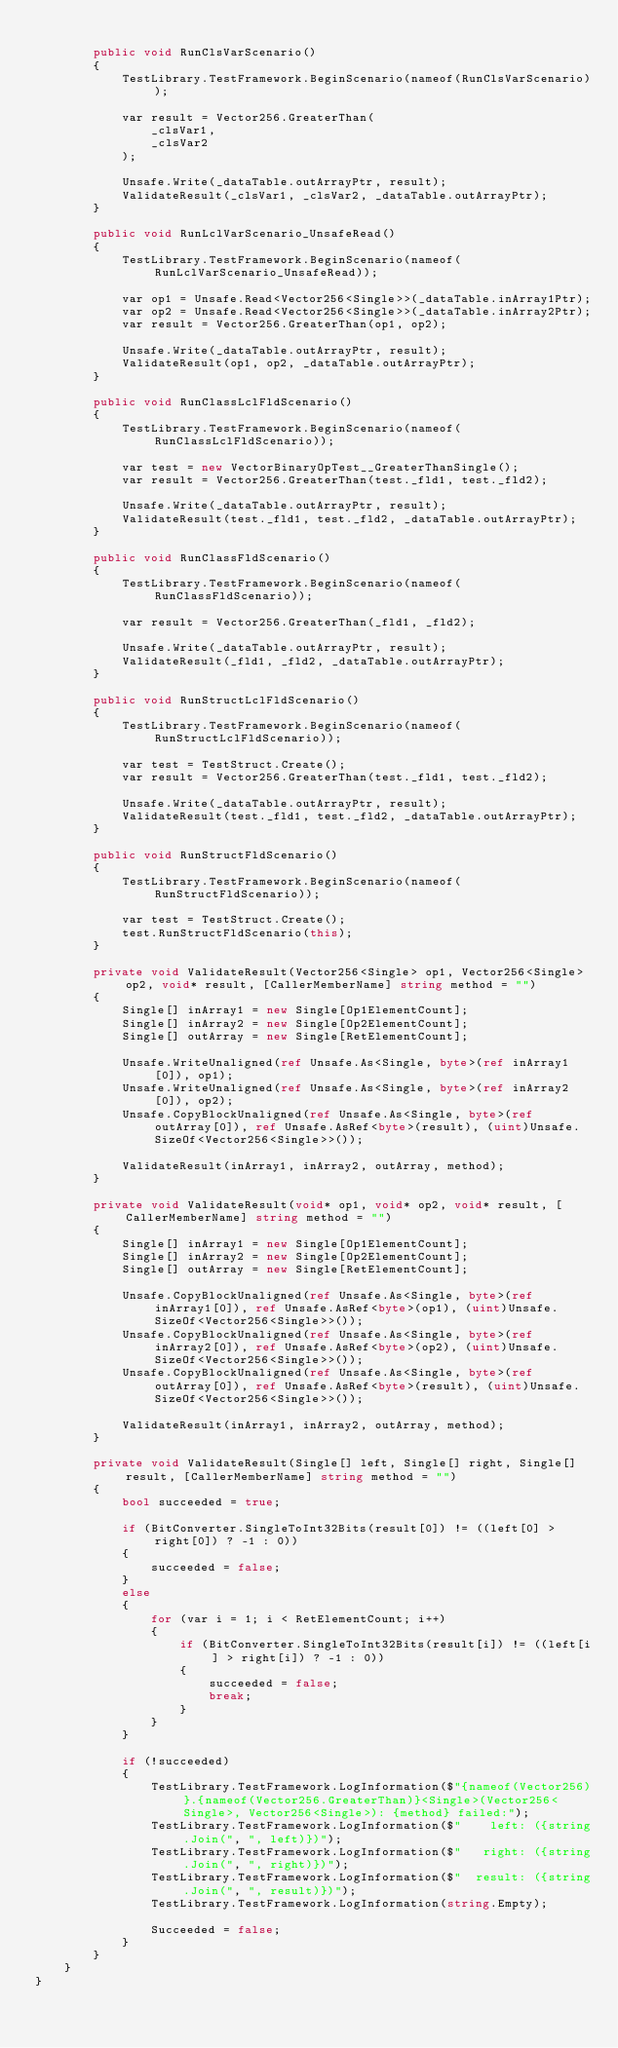Convert code to text. <code><loc_0><loc_0><loc_500><loc_500><_C#_>
        public void RunClsVarScenario()
        {
            TestLibrary.TestFramework.BeginScenario(nameof(RunClsVarScenario));

            var result = Vector256.GreaterThan(
                _clsVar1,
                _clsVar2
            );

            Unsafe.Write(_dataTable.outArrayPtr, result);
            ValidateResult(_clsVar1, _clsVar2, _dataTable.outArrayPtr);
        }

        public void RunLclVarScenario_UnsafeRead()
        {
            TestLibrary.TestFramework.BeginScenario(nameof(RunLclVarScenario_UnsafeRead));

            var op1 = Unsafe.Read<Vector256<Single>>(_dataTable.inArray1Ptr);
            var op2 = Unsafe.Read<Vector256<Single>>(_dataTable.inArray2Ptr);
            var result = Vector256.GreaterThan(op1, op2);

            Unsafe.Write(_dataTable.outArrayPtr, result);
            ValidateResult(op1, op2, _dataTable.outArrayPtr);
        }

        public void RunClassLclFldScenario()
        {
            TestLibrary.TestFramework.BeginScenario(nameof(RunClassLclFldScenario));

            var test = new VectorBinaryOpTest__GreaterThanSingle();
            var result = Vector256.GreaterThan(test._fld1, test._fld2);

            Unsafe.Write(_dataTable.outArrayPtr, result);
            ValidateResult(test._fld1, test._fld2, _dataTable.outArrayPtr);
        }

        public void RunClassFldScenario()
        {
            TestLibrary.TestFramework.BeginScenario(nameof(RunClassFldScenario));

            var result = Vector256.GreaterThan(_fld1, _fld2);

            Unsafe.Write(_dataTable.outArrayPtr, result);
            ValidateResult(_fld1, _fld2, _dataTable.outArrayPtr);
        }

        public void RunStructLclFldScenario()
        {
            TestLibrary.TestFramework.BeginScenario(nameof(RunStructLclFldScenario));

            var test = TestStruct.Create();
            var result = Vector256.GreaterThan(test._fld1, test._fld2);

            Unsafe.Write(_dataTable.outArrayPtr, result);
            ValidateResult(test._fld1, test._fld2, _dataTable.outArrayPtr);
        }

        public void RunStructFldScenario()
        {
            TestLibrary.TestFramework.BeginScenario(nameof(RunStructFldScenario));

            var test = TestStruct.Create();
            test.RunStructFldScenario(this);
        }

        private void ValidateResult(Vector256<Single> op1, Vector256<Single> op2, void* result, [CallerMemberName] string method = "")
        {
            Single[] inArray1 = new Single[Op1ElementCount];
            Single[] inArray2 = new Single[Op2ElementCount];
            Single[] outArray = new Single[RetElementCount];

            Unsafe.WriteUnaligned(ref Unsafe.As<Single, byte>(ref inArray1[0]), op1);
            Unsafe.WriteUnaligned(ref Unsafe.As<Single, byte>(ref inArray2[0]), op2);
            Unsafe.CopyBlockUnaligned(ref Unsafe.As<Single, byte>(ref outArray[0]), ref Unsafe.AsRef<byte>(result), (uint)Unsafe.SizeOf<Vector256<Single>>());

            ValidateResult(inArray1, inArray2, outArray, method);
        }

        private void ValidateResult(void* op1, void* op2, void* result, [CallerMemberName] string method = "")
        {
            Single[] inArray1 = new Single[Op1ElementCount];
            Single[] inArray2 = new Single[Op2ElementCount];
            Single[] outArray = new Single[RetElementCount];

            Unsafe.CopyBlockUnaligned(ref Unsafe.As<Single, byte>(ref inArray1[0]), ref Unsafe.AsRef<byte>(op1), (uint)Unsafe.SizeOf<Vector256<Single>>());
            Unsafe.CopyBlockUnaligned(ref Unsafe.As<Single, byte>(ref inArray2[0]), ref Unsafe.AsRef<byte>(op2), (uint)Unsafe.SizeOf<Vector256<Single>>());
            Unsafe.CopyBlockUnaligned(ref Unsafe.As<Single, byte>(ref outArray[0]), ref Unsafe.AsRef<byte>(result), (uint)Unsafe.SizeOf<Vector256<Single>>());

            ValidateResult(inArray1, inArray2, outArray, method);
        }

        private void ValidateResult(Single[] left, Single[] right, Single[] result, [CallerMemberName] string method = "")
        {
            bool succeeded = true;

            if (BitConverter.SingleToInt32Bits(result[0]) != ((left[0] > right[0]) ? -1 : 0))
            {
                succeeded = false;
            }
            else
            {
                for (var i = 1; i < RetElementCount; i++)
                {
                    if (BitConverter.SingleToInt32Bits(result[i]) != ((left[i] > right[i]) ? -1 : 0))
                    {
                        succeeded = false;
                        break;
                    }
                }
            }

            if (!succeeded)
            {
                TestLibrary.TestFramework.LogInformation($"{nameof(Vector256)}.{nameof(Vector256.GreaterThan)}<Single>(Vector256<Single>, Vector256<Single>): {method} failed:");
                TestLibrary.TestFramework.LogInformation($"    left: ({string.Join(", ", left)})");
                TestLibrary.TestFramework.LogInformation($"   right: ({string.Join(", ", right)})");
                TestLibrary.TestFramework.LogInformation($"  result: ({string.Join(", ", result)})");
                TestLibrary.TestFramework.LogInformation(string.Empty);

                Succeeded = false;
            }
        }
    }
}
</code> 